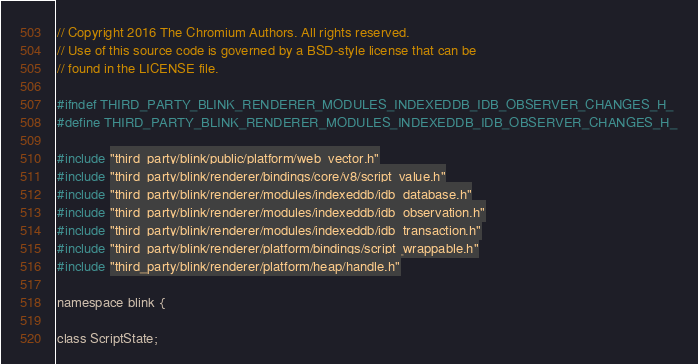Convert code to text. <code><loc_0><loc_0><loc_500><loc_500><_C_>// Copyright 2016 The Chromium Authors. All rights reserved.
// Use of this source code is governed by a BSD-style license that can be
// found in the LICENSE file.

#ifndef THIRD_PARTY_BLINK_RENDERER_MODULES_INDEXEDDB_IDB_OBSERVER_CHANGES_H_
#define THIRD_PARTY_BLINK_RENDERER_MODULES_INDEXEDDB_IDB_OBSERVER_CHANGES_H_

#include "third_party/blink/public/platform/web_vector.h"
#include "third_party/blink/renderer/bindings/core/v8/script_value.h"
#include "third_party/blink/renderer/modules/indexeddb/idb_database.h"
#include "third_party/blink/renderer/modules/indexeddb/idb_observation.h"
#include "third_party/blink/renderer/modules/indexeddb/idb_transaction.h"
#include "third_party/blink/renderer/platform/bindings/script_wrappable.h"
#include "third_party/blink/renderer/platform/heap/handle.h"

namespace blink {

class ScriptState;
</code> 